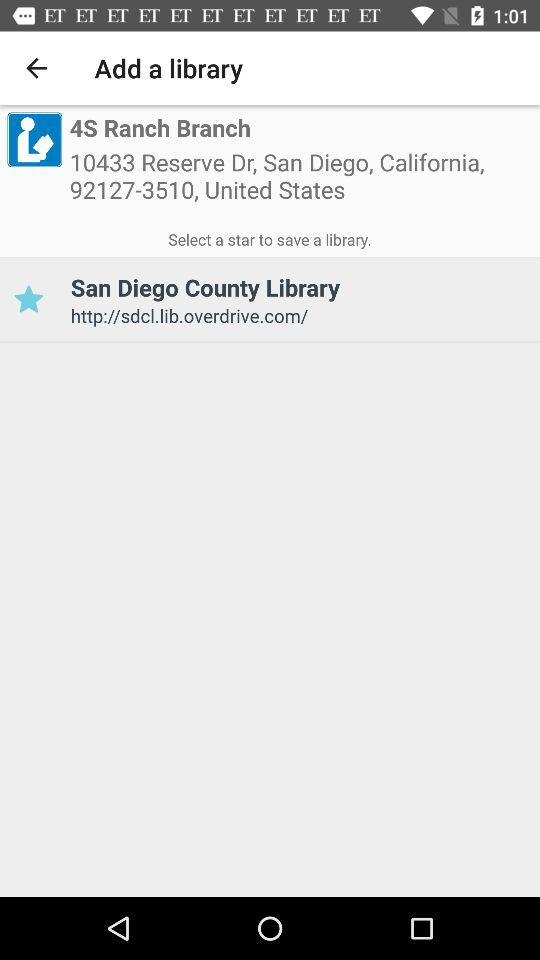What is the mobile number of the branch? The mobile number of the branch is 92127-3510. 